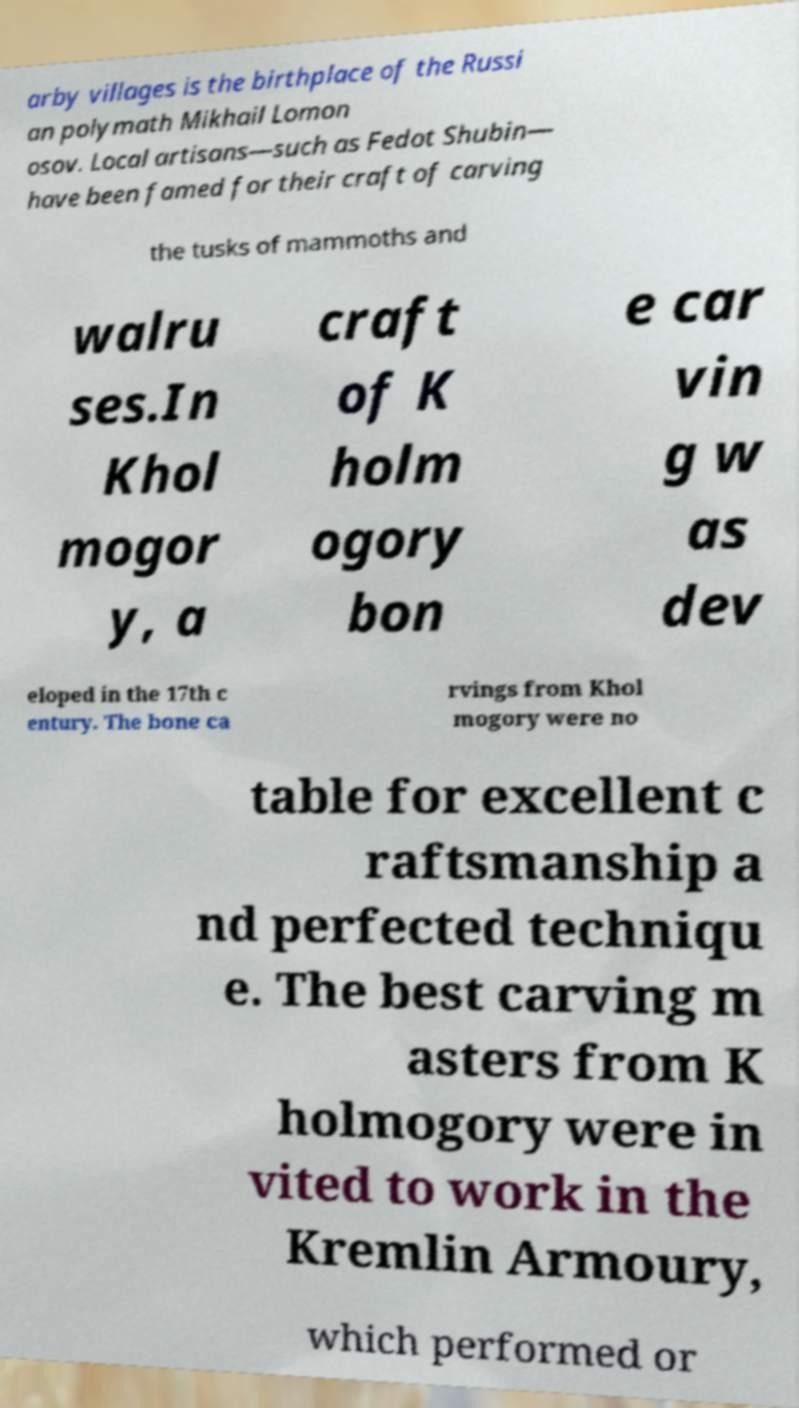Please read and relay the text visible in this image. What does it say? arby villages is the birthplace of the Russi an polymath Mikhail Lomon osov. Local artisans—such as Fedot Shubin— have been famed for their craft of carving the tusks of mammoths and walru ses.In Khol mogor y, a craft of K holm ogory bon e car vin g w as dev eloped in the 17th c entury. The bone ca rvings from Khol mogory were no table for excellent c raftsmanship a nd perfected techniqu e. The best carving m asters from K holmogory were in vited to work in the Kremlin Armoury, which performed or 